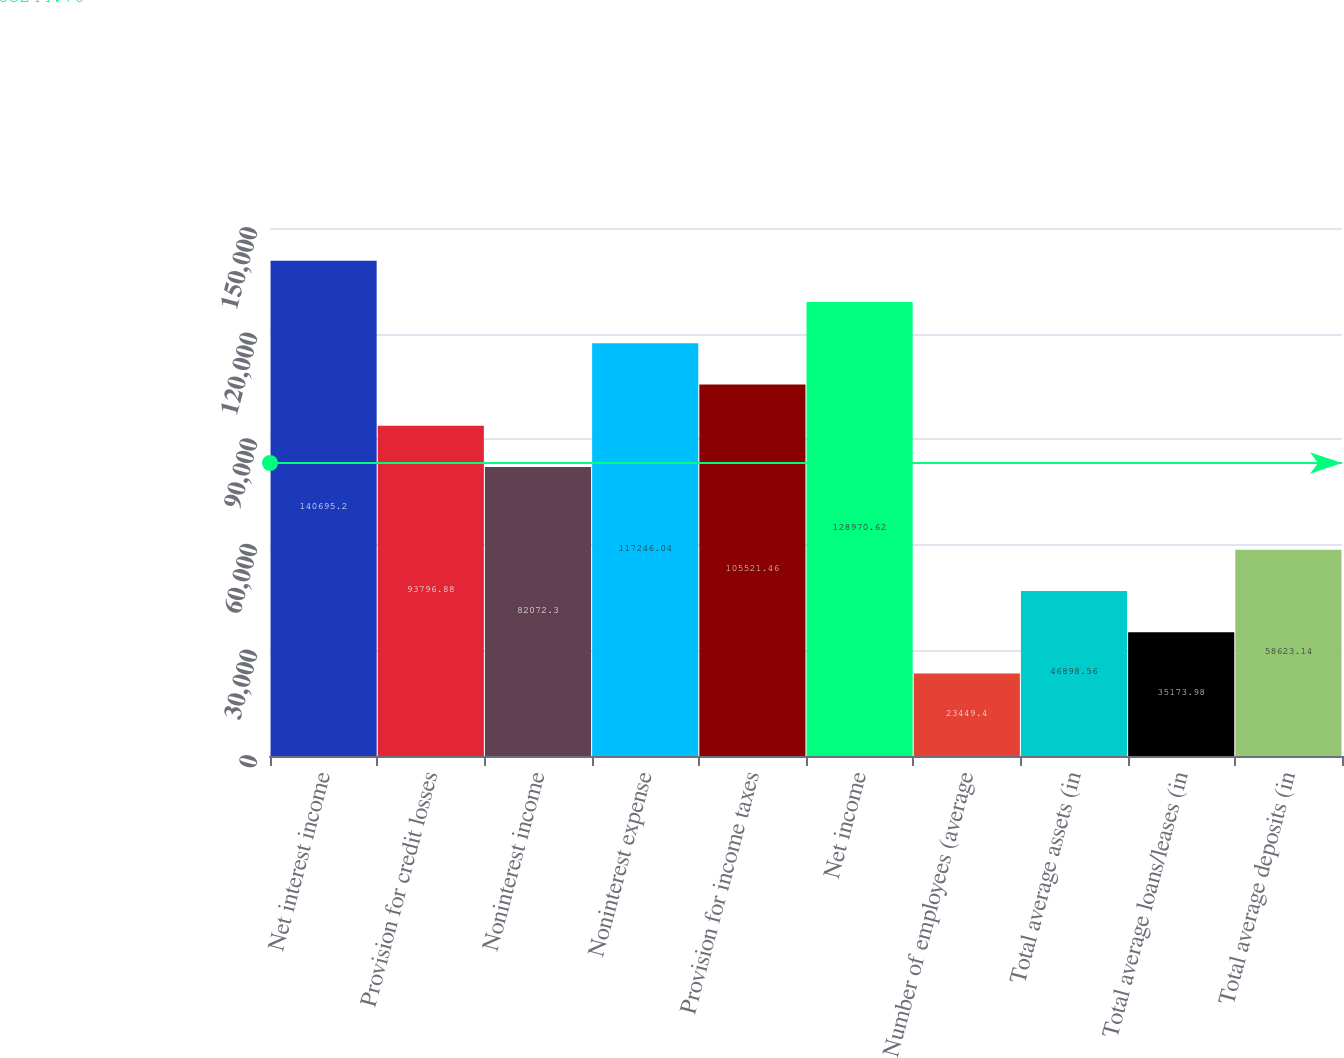Convert chart. <chart><loc_0><loc_0><loc_500><loc_500><bar_chart><fcel>Net interest income<fcel>Provision for credit losses<fcel>Noninterest income<fcel>Noninterest expense<fcel>Provision for income taxes<fcel>Net income<fcel>Number of employees (average<fcel>Total average assets (in<fcel>Total average loans/leases (in<fcel>Total average deposits (in<nl><fcel>140695<fcel>93796.9<fcel>82072.3<fcel>117246<fcel>105521<fcel>128971<fcel>23449.4<fcel>46898.6<fcel>35174<fcel>58623.1<nl></chart> 